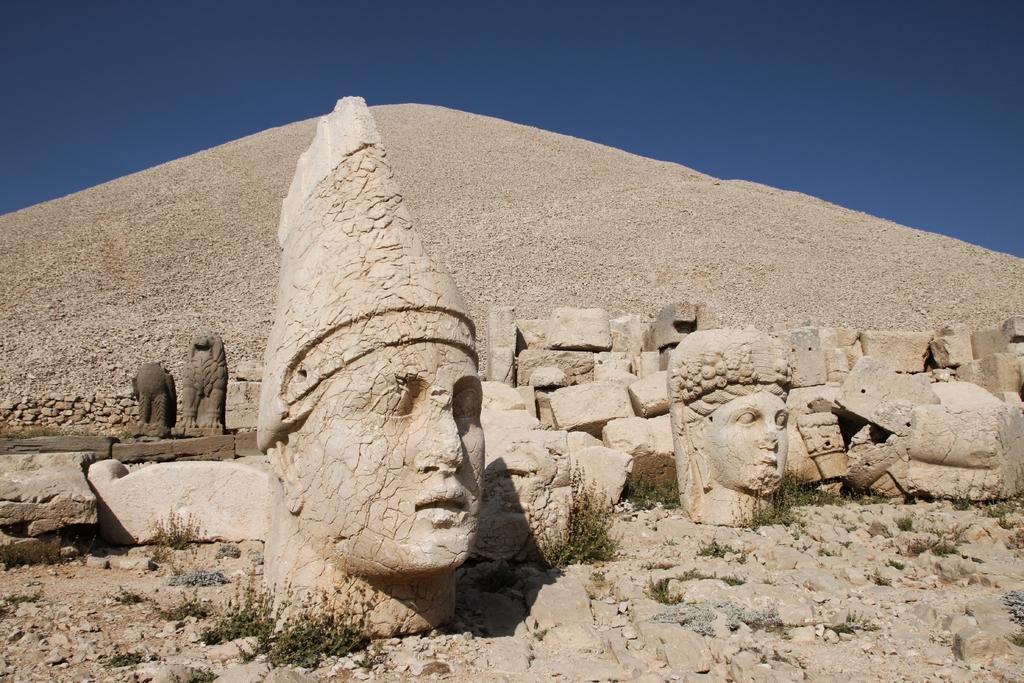What can be found at the bottom of the image? There are sculptures at the bottom of the image. What structure is visible behind the sculptures? There is a pyramid behind the sculptures. What is visible at the top of the image? The sky is visible at the top of the image. Where is the tent located in the image? There is no tent present in the image. What type of unit is being sold in the market in the image? There is no market or unit present in the image. 